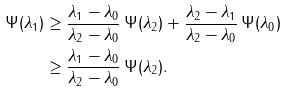Convert formula to latex. <formula><loc_0><loc_0><loc_500><loc_500>\Psi ( \lambda _ { 1 } ) & \geq \frac { \lambda _ { 1 } - \lambda _ { 0 } } { \lambda _ { 2 } - \lambda _ { 0 } } \, \Psi ( \lambda _ { 2 } ) + \frac { \lambda _ { 2 } - \lambda _ { 1 } } { \lambda _ { 2 } - \lambda _ { 0 } } \, \Psi ( \lambda _ { 0 } ) \\ & \geq \frac { \lambda _ { 1 } - \lambda _ { 0 } } { \lambda _ { 2 } - \lambda _ { 0 } } \, \Psi ( \lambda _ { 2 } ) .</formula> 